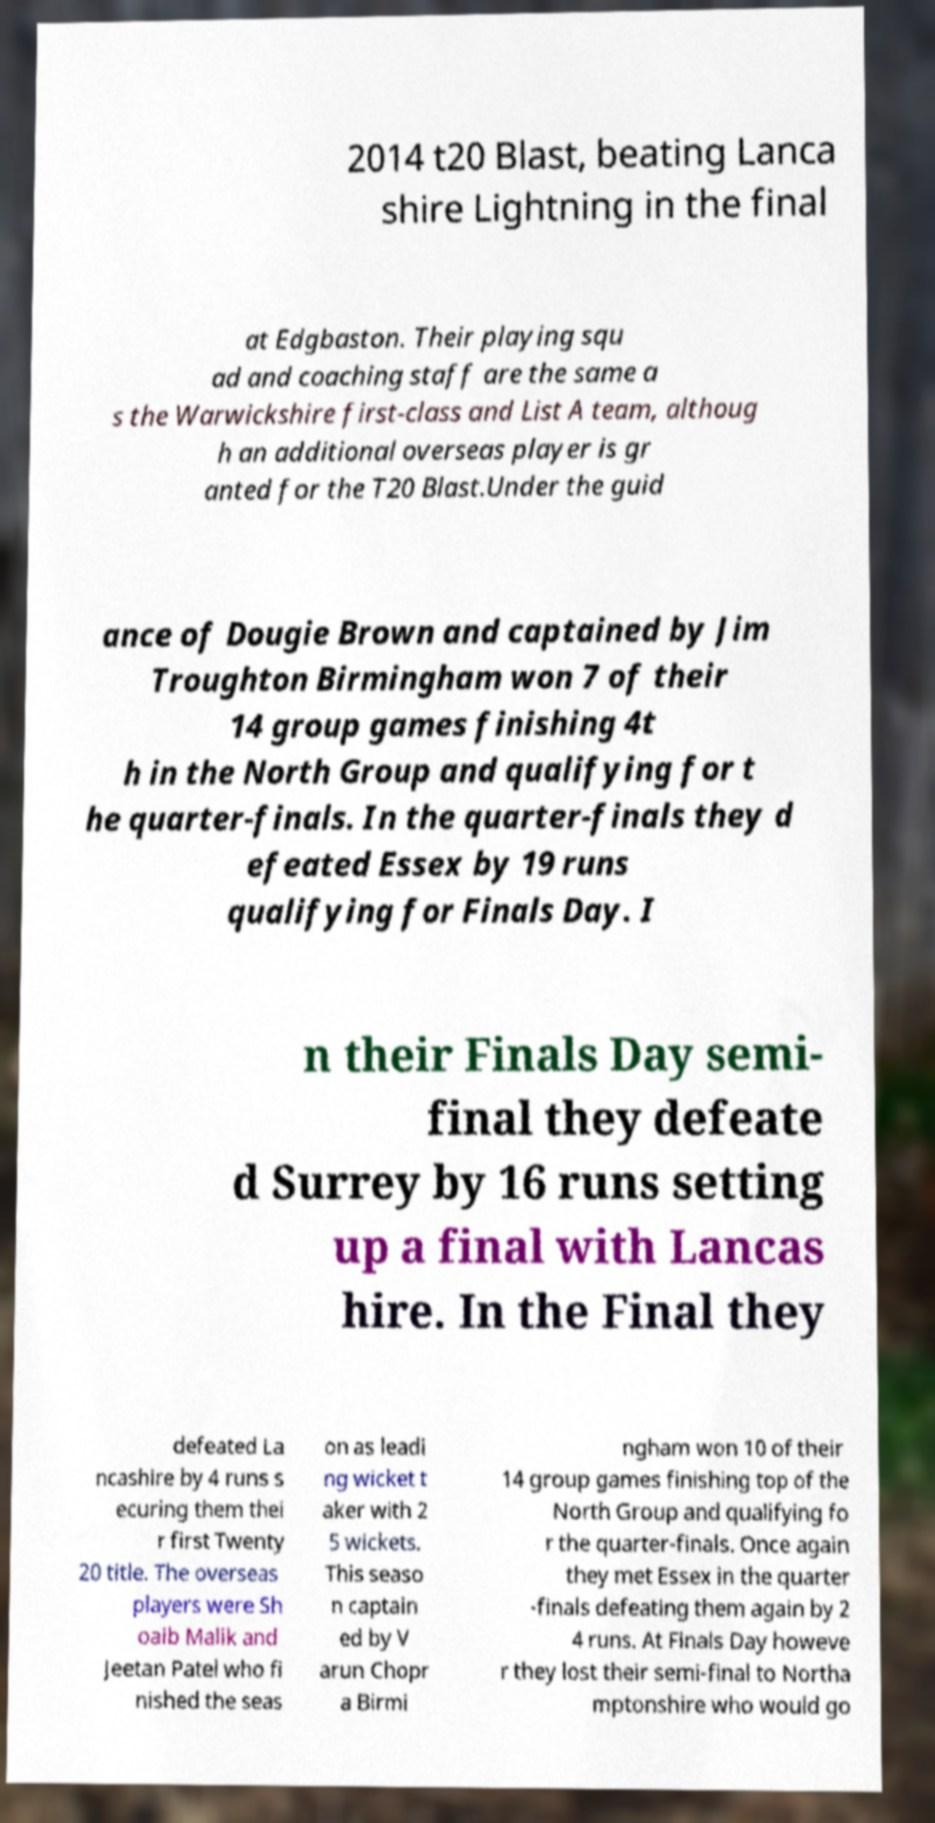Could you assist in decoding the text presented in this image and type it out clearly? 2014 t20 Blast, beating Lanca shire Lightning in the final at Edgbaston. Their playing squ ad and coaching staff are the same a s the Warwickshire first-class and List A team, althoug h an additional overseas player is gr anted for the T20 Blast.Under the guid ance of Dougie Brown and captained by Jim Troughton Birmingham won 7 of their 14 group games finishing 4t h in the North Group and qualifying for t he quarter-finals. In the quarter-finals they d efeated Essex by 19 runs qualifying for Finals Day. I n their Finals Day semi- final they defeate d Surrey by 16 runs setting up a final with Lancas hire. In the Final they defeated La ncashire by 4 runs s ecuring them thei r first Twenty 20 title. The overseas players were Sh oaib Malik and Jeetan Patel who fi nished the seas on as leadi ng wicket t aker with 2 5 wickets. This seaso n captain ed by V arun Chopr a Birmi ngham won 10 of their 14 group games finishing top of the North Group and qualifying fo r the quarter-finals. Once again they met Essex in the quarter -finals defeating them again by 2 4 runs. At Finals Day howeve r they lost their semi-final to Northa mptonshire who would go 